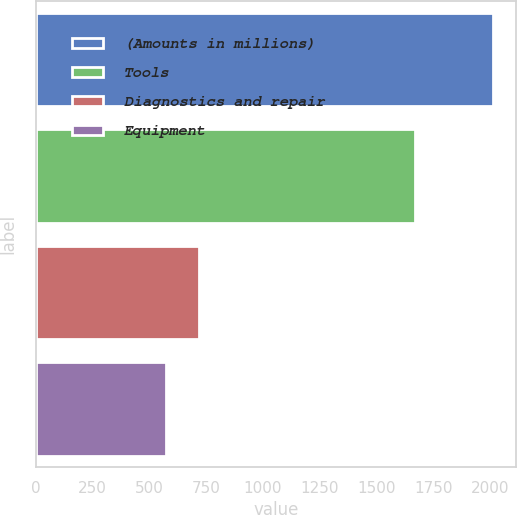Convert chart. <chart><loc_0><loc_0><loc_500><loc_500><bar_chart><fcel>(Amounts in millions)<fcel>Tools<fcel>Diagnostics and repair<fcel>Equipment<nl><fcel>2011<fcel>1667.3<fcel>716.98<fcel>573.2<nl></chart> 